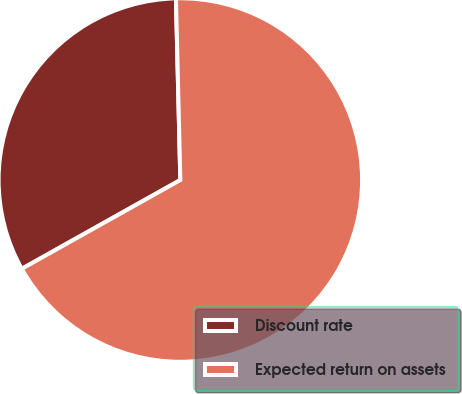Convert chart to OTSL. <chart><loc_0><loc_0><loc_500><loc_500><pie_chart><fcel>Discount rate<fcel>Expected return on assets<nl><fcel>32.74%<fcel>67.26%<nl></chart> 